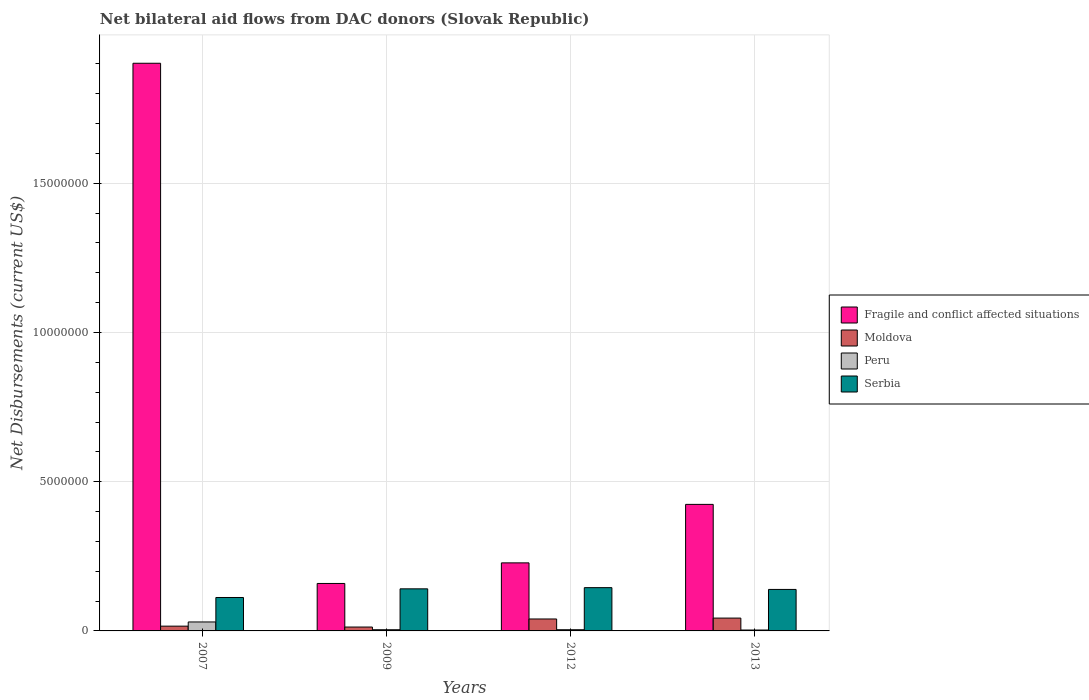How many groups of bars are there?
Offer a terse response. 4. Are the number of bars on each tick of the X-axis equal?
Provide a short and direct response. Yes. How many bars are there on the 1st tick from the left?
Offer a very short reply. 4. What is the label of the 3rd group of bars from the left?
Make the answer very short. 2012. In how many cases, is the number of bars for a given year not equal to the number of legend labels?
Offer a very short reply. 0. What is the net bilateral aid flows in Moldova in 2009?
Offer a terse response. 1.30e+05. Across all years, what is the maximum net bilateral aid flows in Moldova?
Your response must be concise. 4.30e+05. Across all years, what is the minimum net bilateral aid flows in Fragile and conflict affected situations?
Provide a short and direct response. 1.59e+06. In which year was the net bilateral aid flows in Peru maximum?
Make the answer very short. 2007. What is the difference between the net bilateral aid flows in Fragile and conflict affected situations in 2012 and that in 2013?
Your answer should be compact. -1.96e+06. What is the difference between the net bilateral aid flows in Fragile and conflict affected situations in 2007 and the net bilateral aid flows in Serbia in 2012?
Provide a succinct answer. 1.76e+07. What is the average net bilateral aid flows in Moldova per year?
Give a very brief answer. 2.80e+05. In the year 2013, what is the difference between the net bilateral aid flows in Peru and net bilateral aid flows in Serbia?
Provide a short and direct response. -1.36e+06. Is the net bilateral aid flows in Moldova in 2007 less than that in 2013?
Offer a terse response. Yes. Is the difference between the net bilateral aid flows in Peru in 2007 and 2009 greater than the difference between the net bilateral aid flows in Serbia in 2007 and 2009?
Give a very brief answer. Yes. What is the difference between the highest and the second highest net bilateral aid flows in Serbia?
Your answer should be compact. 4.00e+04. Is the sum of the net bilateral aid flows in Serbia in 2007 and 2013 greater than the maximum net bilateral aid flows in Peru across all years?
Offer a very short reply. Yes. What does the 1st bar from the left in 2012 represents?
Provide a succinct answer. Fragile and conflict affected situations. What does the 4th bar from the right in 2009 represents?
Give a very brief answer. Fragile and conflict affected situations. How many bars are there?
Your answer should be compact. 16. Are all the bars in the graph horizontal?
Offer a terse response. No. How many years are there in the graph?
Offer a terse response. 4. What is the difference between two consecutive major ticks on the Y-axis?
Provide a succinct answer. 5.00e+06. Are the values on the major ticks of Y-axis written in scientific E-notation?
Provide a succinct answer. No. Does the graph contain any zero values?
Keep it short and to the point. No. How are the legend labels stacked?
Keep it short and to the point. Vertical. What is the title of the graph?
Offer a terse response. Net bilateral aid flows from DAC donors (Slovak Republic). Does "Sao Tome and Principe" appear as one of the legend labels in the graph?
Your answer should be compact. No. What is the label or title of the X-axis?
Your answer should be very brief. Years. What is the label or title of the Y-axis?
Provide a succinct answer. Net Disbursements (current US$). What is the Net Disbursements (current US$) of Fragile and conflict affected situations in 2007?
Make the answer very short. 1.90e+07. What is the Net Disbursements (current US$) in Moldova in 2007?
Your answer should be very brief. 1.60e+05. What is the Net Disbursements (current US$) in Serbia in 2007?
Provide a short and direct response. 1.12e+06. What is the Net Disbursements (current US$) in Fragile and conflict affected situations in 2009?
Give a very brief answer. 1.59e+06. What is the Net Disbursements (current US$) of Serbia in 2009?
Your answer should be very brief. 1.41e+06. What is the Net Disbursements (current US$) of Fragile and conflict affected situations in 2012?
Make the answer very short. 2.28e+06. What is the Net Disbursements (current US$) of Serbia in 2012?
Give a very brief answer. 1.45e+06. What is the Net Disbursements (current US$) of Fragile and conflict affected situations in 2013?
Your response must be concise. 4.24e+06. What is the Net Disbursements (current US$) of Serbia in 2013?
Provide a short and direct response. 1.39e+06. Across all years, what is the maximum Net Disbursements (current US$) of Fragile and conflict affected situations?
Your answer should be very brief. 1.90e+07. Across all years, what is the maximum Net Disbursements (current US$) in Moldova?
Provide a succinct answer. 4.30e+05. Across all years, what is the maximum Net Disbursements (current US$) of Serbia?
Offer a very short reply. 1.45e+06. Across all years, what is the minimum Net Disbursements (current US$) in Fragile and conflict affected situations?
Ensure brevity in your answer.  1.59e+06. Across all years, what is the minimum Net Disbursements (current US$) in Moldova?
Make the answer very short. 1.30e+05. Across all years, what is the minimum Net Disbursements (current US$) of Serbia?
Provide a succinct answer. 1.12e+06. What is the total Net Disbursements (current US$) in Fragile and conflict affected situations in the graph?
Your answer should be compact. 2.71e+07. What is the total Net Disbursements (current US$) in Moldova in the graph?
Ensure brevity in your answer.  1.12e+06. What is the total Net Disbursements (current US$) of Peru in the graph?
Give a very brief answer. 4.10e+05. What is the total Net Disbursements (current US$) in Serbia in the graph?
Offer a terse response. 5.37e+06. What is the difference between the Net Disbursements (current US$) of Fragile and conflict affected situations in 2007 and that in 2009?
Make the answer very short. 1.74e+07. What is the difference between the Net Disbursements (current US$) in Moldova in 2007 and that in 2009?
Keep it short and to the point. 3.00e+04. What is the difference between the Net Disbursements (current US$) in Peru in 2007 and that in 2009?
Make the answer very short. 2.60e+05. What is the difference between the Net Disbursements (current US$) of Serbia in 2007 and that in 2009?
Provide a succinct answer. -2.90e+05. What is the difference between the Net Disbursements (current US$) in Fragile and conflict affected situations in 2007 and that in 2012?
Give a very brief answer. 1.67e+07. What is the difference between the Net Disbursements (current US$) in Moldova in 2007 and that in 2012?
Provide a short and direct response. -2.40e+05. What is the difference between the Net Disbursements (current US$) in Serbia in 2007 and that in 2012?
Your answer should be very brief. -3.30e+05. What is the difference between the Net Disbursements (current US$) of Fragile and conflict affected situations in 2007 and that in 2013?
Give a very brief answer. 1.48e+07. What is the difference between the Net Disbursements (current US$) in Moldova in 2007 and that in 2013?
Your answer should be compact. -2.70e+05. What is the difference between the Net Disbursements (current US$) in Peru in 2007 and that in 2013?
Your response must be concise. 2.70e+05. What is the difference between the Net Disbursements (current US$) of Fragile and conflict affected situations in 2009 and that in 2012?
Offer a very short reply. -6.90e+05. What is the difference between the Net Disbursements (current US$) in Moldova in 2009 and that in 2012?
Your answer should be very brief. -2.70e+05. What is the difference between the Net Disbursements (current US$) of Fragile and conflict affected situations in 2009 and that in 2013?
Provide a short and direct response. -2.65e+06. What is the difference between the Net Disbursements (current US$) of Moldova in 2009 and that in 2013?
Keep it short and to the point. -3.00e+05. What is the difference between the Net Disbursements (current US$) of Peru in 2009 and that in 2013?
Keep it short and to the point. 10000. What is the difference between the Net Disbursements (current US$) of Fragile and conflict affected situations in 2012 and that in 2013?
Offer a very short reply. -1.96e+06. What is the difference between the Net Disbursements (current US$) of Moldova in 2012 and that in 2013?
Ensure brevity in your answer.  -3.00e+04. What is the difference between the Net Disbursements (current US$) of Peru in 2012 and that in 2013?
Offer a very short reply. 10000. What is the difference between the Net Disbursements (current US$) in Serbia in 2012 and that in 2013?
Make the answer very short. 6.00e+04. What is the difference between the Net Disbursements (current US$) in Fragile and conflict affected situations in 2007 and the Net Disbursements (current US$) in Moldova in 2009?
Provide a short and direct response. 1.89e+07. What is the difference between the Net Disbursements (current US$) of Fragile and conflict affected situations in 2007 and the Net Disbursements (current US$) of Peru in 2009?
Make the answer very short. 1.90e+07. What is the difference between the Net Disbursements (current US$) of Fragile and conflict affected situations in 2007 and the Net Disbursements (current US$) of Serbia in 2009?
Your answer should be very brief. 1.76e+07. What is the difference between the Net Disbursements (current US$) of Moldova in 2007 and the Net Disbursements (current US$) of Peru in 2009?
Give a very brief answer. 1.20e+05. What is the difference between the Net Disbursements (current US$) of Moldova in 2007 and the Net Disbursements (current US$) of Serbia in 2009?
Ensure brevity in your answer.  -1.25e+06. What is the difference between the Net Disbursements (current US$) in Peru in 2007 and the Net Disbursements (current US$) in Serbia in 2009?
Provide a succinct answer. -1.11e+06. What is the difference between the Net Disbursements (current US$) of Fragile and conflict affected situations in 2007 and the Net Disbursements (current US$) of Moldova in 2012?
Keep it short and to the point. 1.86e+07. What is the difference between the Net Disbursements (current US$) of Fragile and conflict affected situations in 2007 and the Net Disbursements (current US$) of Peru in 2012?
Offer a terse response. 1.90e+07. What is the difference between the Net Disbursements (current US$) in Fragile and conflict affected situations in 2007 and the Net Disbursements (current US$) in Serbia in 2012?
Ensure brevity in your answer.  1.76e+07. What is the difference between the Net Disbursements (current US$) of Moldova in 2007 and the Net Disbursements (current US$) of Peru in 2012?
Offer a very short reply. 1.20e+05. What is the difference between the Net Disbursements (current US$) of Moldova in 2007 and the Net Disbursements (current US$) of Serbia in 2012?
Offer a very short reply. -1.29e+06. What is the difference between the Net Disbursements (current US$) of Peru in 2007 and the Net Disbursements (current US$) of Serbia in 2012?
Your response must be concise. -1.15e+06. What is the difference between the Net Disbursements (current US$) in Fragile and conflict affected situations in 2007 and the Net Disbursements (current US$) in Moldova in 2013?
Offer a very short reply. 1.86e+07. What is the difference between the Net Disbursements (current US$) in Fragile and conflict affected situations in 2007 and the Net Disbursements (current US$) in Peru in 2013?
Your answer should be very brief. 1.90e+07. What is the difference between the Net Disbursements (current US$) of Fragile and conflict affected situations in 2007 and the Net Disbursements (current US$) of Serbia in 2013?
Provide a succinct answer. 1.76e+07. What is the difference between the Net Disbursements (current US$) of Moldova in 2007 and the Net Disbursements (current US$) of Peru in 2013?
Your answer should be compact. 1.30e+05. What is the difference between the Net Disbursements (current US$) in Moldova in 2007 and the Net Disbursements (current US$) in Serbia in 2013?
Give a very brief answer. -1.23e+06. What is the difference between the Net Disbursements (current US$) of Peru in 2007 and the Net Disbursements (current US$) of Serbia in 2013?
Give a very brief answer. -1.09e+06. What is the difference between the Net Disbursements (current US$) of Fragile and conflict affected situations in 2009 and the Net Disbursements (current US$) of Moldova in 2012?
Your answer should be compact. 1.19e+06. What is the difference between the Net Disbursements (current US$) of Fragile and conflict affected situations in 2009 and the Net Disbursements (current US$) of Peru in 2012?
Your response must be concise. 1.55e+06. What is the difference between the Net Disbursements (current US$) in Moldova in 2009 and the Net Disbursements (current US$) in Peru in 2012?
Keep it short and to the point. 9.00e+04. What is the difference between the Net Disbursements (current US$) of Moldova in 2009 and the Net Disbursements (current US$) of Serbia in 2012?
Offer a very short reply. -1.32e+06. What is the difference between the Net Disbursements (current US$) of Peru in 2009 and the Net Disbursements (current US$) of Serbia in 2012?
Keep it short and to the point. -1.41e+06. What is the difference between the Net Disbursements (current US$) in Fragile and conflict affected situations in 2009 and the Net Disbursements (current US$) in Moldova in 2013?
Ensure brevity in your answer.  1.16e+06. What is the difference between the Net Disbursements (current US$) of Fragile and conflict affected situations in 2009 and the Net Disbursements (current US$) of Peru in 2013?
Provide a succinct answer. 1.56e+06. What is the difference between the Net Disbursements (current US$) of Moldova in 2009 and the Net Disbursements (current US$) of Peru in 2013?
Provide a succinct answer. 1.00e+05. What is the difference between the Net Disbursements (current US$) of Moldova in 2009 and the Net Disbursements (current US$) of Serbia in 2013?
Make the answer very short. -1.26e+06. What is the difference between the Net Disbursements (current US$) of Peru in 2009 and the Net Disbursements (current US$) of Serbia in 2013?
Offer a very short reply. -1.35e+06. What is the difference between the Net Disbursements (current US$) in Fragile and conflict affected situations in 2012 and the Net Disbursements (current US$) in Moldova in 2013?
Offer a terse response. 1.85e+06. What is the difference between the Net Disbursements (current US$) of Fragile and conflict affected situations in 2012 and the Net Disbursements (current US$) of Peru in 2013?
Provide a succinct answer. 2.25e+06. What is the difference between the Net Disbursements (current US$) in Fragile and conflict affected situations in 2012 and the Net Disbursements (current US$) in Serbia in 2013?
Offer a terse response. 8.90e+05. What is the difference between the Net Disbursements (current US$) of Moldova in 2012 and the Net Disbursements (current US$) of Serbia in 2013?
Your response must be concise. -9.90e+05. What is the difference between the Net Disbursements (current US$) of Peru in 2012 and the Net Disbursements (current US$) of Serbia in 2013?
Provide a succinct answer. -1.35e+06. What is the average Net Disbursements (current US$) in Fragile and conflict affected situations per year?
Your answer should be compact. 6.78e+06. What is the average Net Disbursements (current US$) of Moldova per year?
Keep it short and to the point. 2.80e+05. What is the average Net Disbursements (current US$) of Peru per year?
Offer a terse response. 1.02e+05. What is the average Net Disbursements (current US$) of Serbia per year?
Provide a short and direct response. 1.34e+06. In the year 2007, what is the difference between the Net Disbursements (current US$) of Fragile and conflict affected situations and Net Disbursements (current US$) of Moldova?
Ensure brevity in your answer.  1.89e+07. In the year 2007, what is the difference between the Net Disbursements (current US$) of Fragile and conflict affected situations and Net Disbursements (current US$) of Peru?
Ensure brevity in your answer.  1.87e+07. In the year 2007, what is the difference between the Net Disbursements (current US$) of Fragile and conflict affected situations and Net Disbursements (current US$) of Serbia?
Make the answer very short. 1.79e+07. In the year 2007, what is the difference between the Net Disbursements (current US$) in Moldova and Net Disbursements (current US$) in Serbia?
Give a very brief answer. -9.60e+05. In the year 2007, what is the difference between the Net Disbursements (current US$) of Peru and Net Disbursements (current US$) of Serbia?
Your answer should be very brief. -8.20e+05. In the year 2009, what is the difference between the Net Disbursements (current US$) in Fragile and conflict affected situations and Net Disbursements (current US$) in Moldova?
Your response must be concise. 1.46e+06. In the year 2009, what is the difference between the Net Disbursements (current US$) in Fragile and conflict affected situations and Net Disbursements (current US$) in Peru?
Make the answer very short. 1.55e+06. In the year 2009, what is the difference between the Net Disbursements (current US$) of Moldova and Net Disbursements (current US$) of Peru?
Provide a short and direct response. 9.00e+04. In the year 2009, what is the difference between the Net Disbursements (current US$) of Moldova and Net Disbursements (current US$) of Serbia?
Make the answer very short. -1.28e+06. In the year 2009, what is the difference between the Net Disbursements (current US$) of Peru and Net Disbursements (current US$) of Serbia?
Your answer should be very brief. -1.37e+06. In the year 2012, what is the difference between the Net Disbursements (current US$) in Fragile and conflict affected situations and Net Disbursements (current US$) in Moldova?
Your response must be concise. 1.88e+06. In the year 2012, what is the difference between the Net Disbursements (current US$) in Fragile and conflict affected situations and Net Disbursements (current US$) in Peru?
Offer a very short reply. 2.24e+06. In the year 2012, what is the difference between the Net Disbursements (current US$) of Fragile and conflict affected situations and Net Disbursements (current US$) of Serbia?
Provide a short and direct response. 8.30e+05. In the year 2012, what is the difference between the Net Disbursements (current US$) in Moldova and Net Disbursements (current US$) in Serbia?
Offer a very short reply. -1.05e+06. In the year 2012, what is the difference between the Net Disbursements (current US$) of Peru and Net Disbursements (current US$) of Serbia?
Offer a very short reply. -1.41e+06. In the year 2013, what is the difference between the Net Disbursements (current US$) of Fragile and conflict affected situations and Net Disbursements (current US$) of Moldova?
Your response must be concise. 3.81e+06. In the year 2013, what is the difference between the Net Disbursements (current US$) in Fragile and conflict affected situations and Net Disbursements (current US$) in Peru?
Provide a succinct answer. 4.21e+06. In the year 2013, what is the difference between the Net Disbursements (current US$) of Fragile and conflict affected situations and Net Disbursements (current US$) of Serbia?
Provide a succinct answer. 2.85e+06. In the year 2013, what is the difference between the Net Disbursements (current US$) of Moldova and Net Disbursements (current US$) of Serbia?
Offer a very short reply. -9.60e+05. In the year 2013, what is the difference between the Net Disbursements (current US$) of Peru and Net Disbursements (current US$) of Serbia?
Provide a short and direct response. -1.36e+06. What is the ratio of the Net Disbursements (current US$) of Fragile and conflict affected situations in 2007 to that in 2009?
Your response must be concise. 11.96. What is the ratio of the Net Disbursements (current US$) in Moldova in 2007 to that in 2009?
Offer a terse response. 1.23. What is the ratio of the Net Disbursements (current US$) in Serbia in 2007 to that in 2009?
Provide a succinct answer. 0.79. What is the ratio of the Net Disbursements (current US$) of Fragile and conflict affected situations in 2007 to that in 2012?
Provide a short and direct response. 8.34. What is the ratio of the Net Disbursements (current US$) in Moldova in 2007 to that in 2012?
Keep it short and to the point. 0.4. What is the ratio of the Net Disbursements (current US$) of Serbia in 2007 to that in 2012?
Keep it short and to the point. 0.77. What is the ratio of the Net Disbursements (current US$) of Fragile and conflict affected situations in 2007 to that in 2013?
Your answer should be compact. 4.49. What is the ratio of the Net Disbursements (current US$) of Moldova in 2007 to that in 2013?
Make the answer very short. 0.37. What is the ratio of the Net Disbursements (current US$) in Serbia in 2007 to that in 2013?
Keep it short and to the point. 0.81. What is the ratio of the Net Disbursements (current US$) in Fragile and conflict affected situations in 2009 to that in 2012?
Keep it short and to the point. 0.7. What is the ratio of the Net Disbursements (current US$) of Moldova in 2009 to that in 2012?
Your response must be concise. 0.33. What is the ratio of the Net Disbursements (current US$) of Serbia in 2009 to that in 2012?
Your answer should be very brief. 0.97. What is the ratio of the Net Disbursements (current US$) of Fragile and conflict affected situations in 2009 to that in 2013?
Make the answer very short. 0.38. What is the ratio of the Net Disbursements (current US$) of Moldova in 2009 to that in 2013?
Make the answer very short. 0.3. What is the ratio of the Net Disbursements (current US$) in Peru in 2009 to that in 2013?
Your answer should be very brief. 1.33. What is the ratio of the Net Disbursements (current US$) in Serbia in 2009 to that in 2013?
Your response must be concise. 1.01. What is the ratio of the Net Disbursements (current US$) of Fragile and conflict affected situations in 2012 to that in 2013?
Your answer should be compact. 0.54. What is the ratio of the Net Disbursements (current US$) of Moldova in 2012 to that in 2013?
Provide a succinct answer. 0.93. What is the ratio of the Net Disbursements (current US$) in Peru in 2012 to that in 2013?
Keep it short and to the point. 1.33. What is the ratio of the Net Disbursements (current US$) of Serbia in 2012 to that in 2013?
Your answer should be compact. 1.04. What is the difference between the highest and the second highest Net Disbursements (current US$) of Fragile and conflict affected situations?
Offer a very short reply. 1.48e+07. What is the difference between the highest and the second highest Net Disbursements (current US$) of Peru?
Provide a succinct answer. 2.60e+05. What is the difference between the highest and the second highest Net Disbursements (current US$) in Serbia?
Offer a very short reply. 4.00e+04. What is the difference between the highest and the lowest Net Disbursements (current US$) of Fragile and conflict affected situations?
Give a very brief answer. 1.74e+07. What is the difference between the highest and the lowest Net Disbursements (current US$) of Peru?
Keep it short and to the point. 2.70e+05. What is the difference between the highest and the lowest Net Disbursements (current US$) in Serbia?
Your answer should be compact. 3.30e+05. 